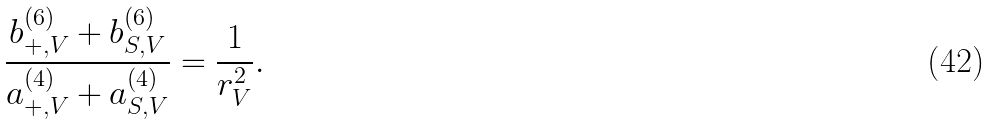Convert formula to latex. <formula><loc_0><loc_0><loc_500><loc_500>\frac { b _ { + , V } ^ { ( 6 ) } + b _ { S , V } ^ { ( 6 ) } } { a _ { + , V } ^ { ( 4 ) } + a _ { S , V } ^ { ( 4 ) } } = \frac { 1 } { r _ { V } ^ { 2 } } .</formula> 